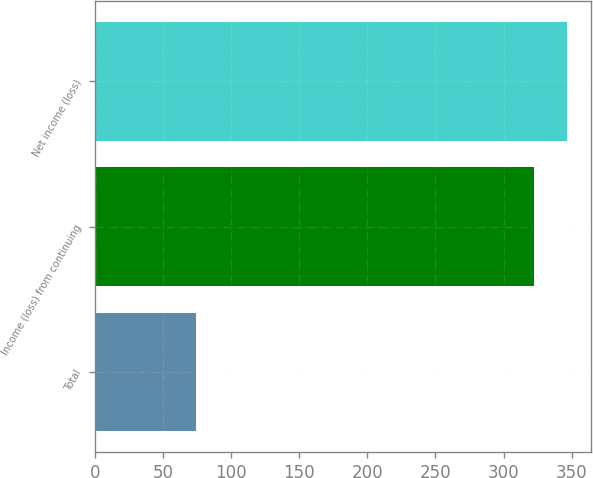Convert chart. <chart><loc_0><loc_0><loc_500><loc_500><bar_chart><fcel>Total<fcel>Income (loss) from continuing<fcel>Net income (loss)<nl><fcel>74<fcel>322<fcel>346.8<nl></chart> 